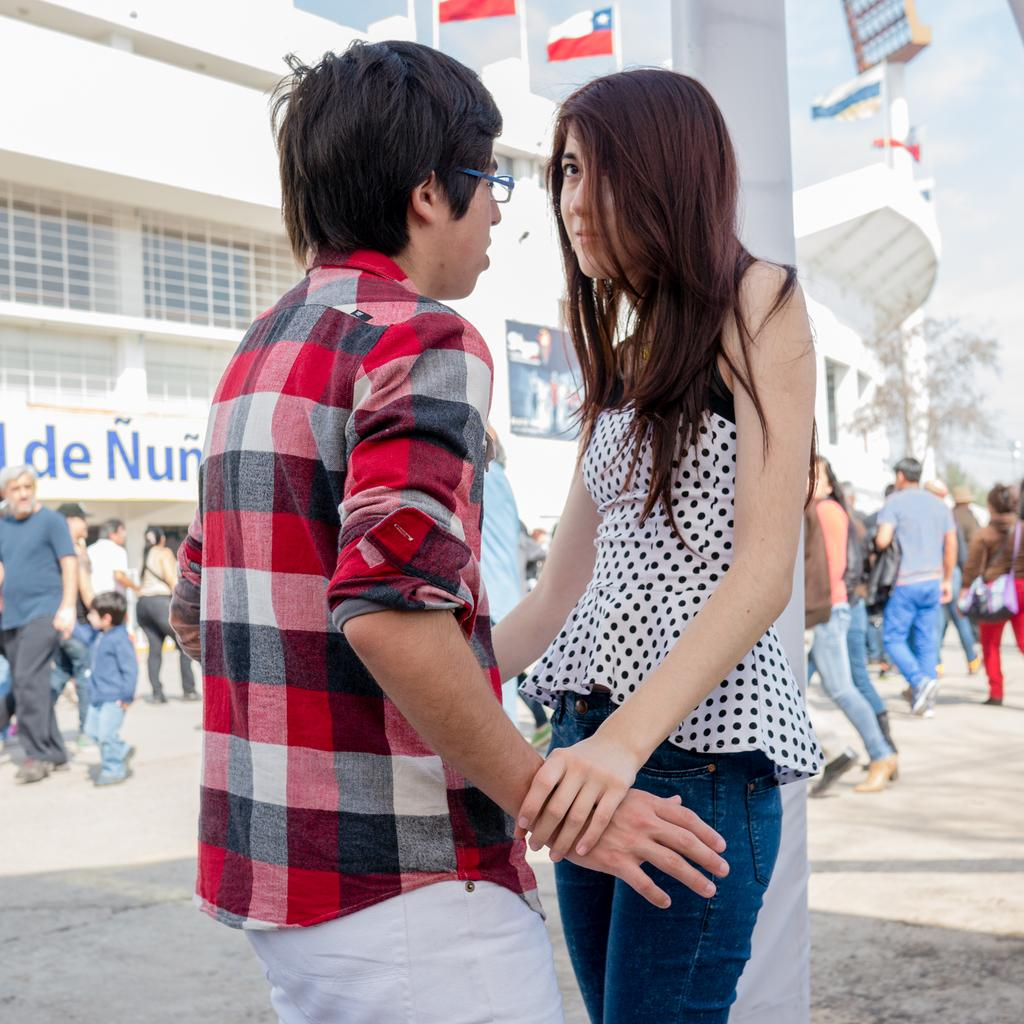How many people are in the image? There are people in the image, but the exact number cannot be determined from the provided facts. What is the pole used for in the image? The purpose of the pole cannot be determined from the provided facts. What can be seen in the background of the image? In the background of the image, there is a building, a poster, a board, flags, trees, and the sky. What type of structure is visible in the background of the image? The building in the background of the image is the only structure mentioned, but its type cannot be determined from the provided facts. Can you see an airplane in the image? No, there is no mention of an airplane in the image. What type of rest can be seen in the image? There is no mention of rest in the image. Is there a train visible in the image? No, there is no mention of a train in the image. 